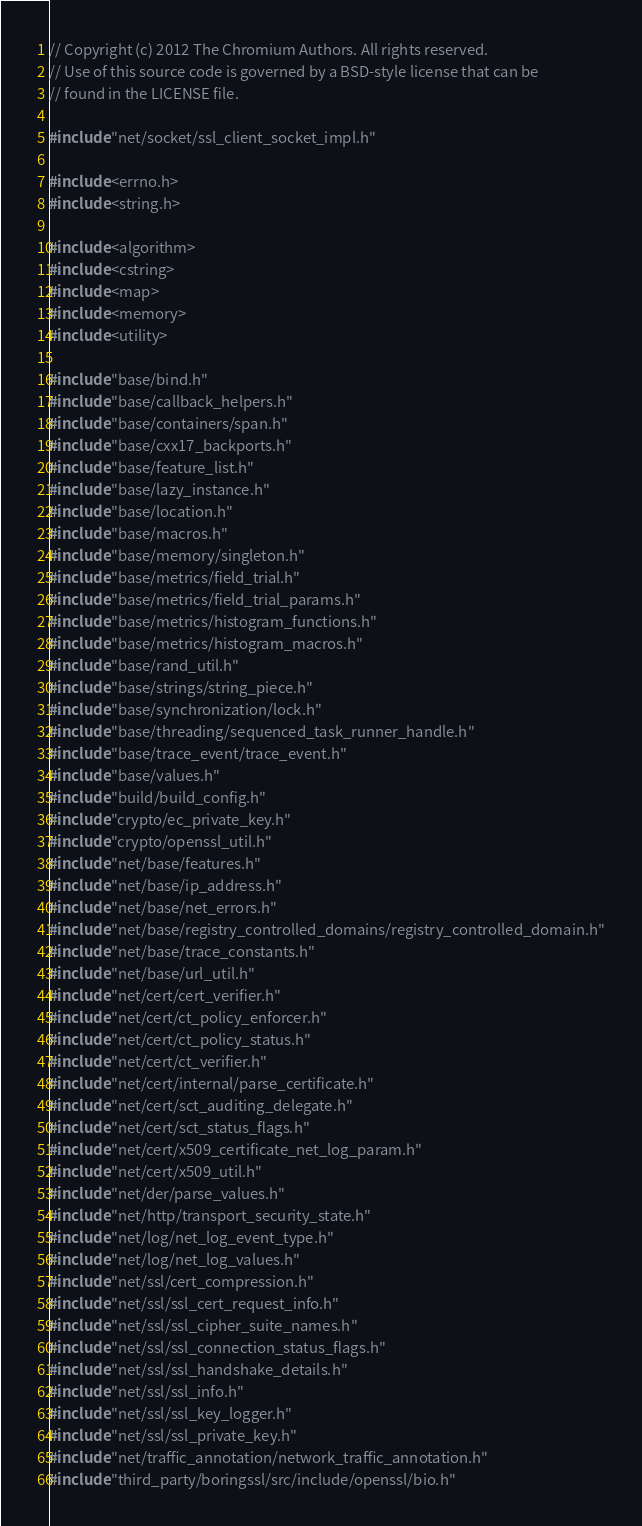Convert code to text. <code><loc_0><loc_0><loc_500><loc_500><_C++_>// Copyright (c) 2012 The Chromium Authors. All rights reserved.
// Use of this source code is governed by a BSD-style license that can be
// found in the LICENSE file.

#include "net/socket/ssl_client_socket_impl.h"

#include <errno.h>
#include <string.h>

#include <algorithm>
#include <cstring>
#include <map>
#include <memory>
#include <utility>

#include "base/bind.h"
#include "base/callback_helpers.h"
#include "base/containers/span.h"
#include "base/cxx17_backports.h"
#include "base/feature_list.h"
#include "base/lazy_instance.h"
#include "base/location.h"
#include "base/macros.h"
#include "base/memory/singleton.h"
#include "base/metrics/field_trial.h"
#include "base/metrics/field_trial_params.h"
#include "base/metrics/histogram_functions.h"
#include "base/metrics/histogram_macros.h"
#include "base/rand_util.h"
#include "base/strings/string_piece.h"
#include "base/synchronization/lock.h"
#include "base/threading/sequenced_task_runner_handle.h"
#include "base/trace_event/trace_event.h"
#include "base/values.h"
#include "build/build_config.h"
#include "crypto/ec_private_key.h"
#include "crypto/openssl_util.h"
#include "net/base/features.h"
#include "net/base/ip_address.h"
#include "net/base/net_errors.h"
#include "net/base/registry_controlled_domains/registry_controlled_domain.h"
#include "net/base/trace_constants.h"
#include "net/base/url_util.h"
#include "net/cert/cert_verifier.h"
#include "net/cert/ct_policy_enforcer.h"
#include "net/cert/ct_policy_status.h"
#include "net/cert/ct_verifier.h"
#include "net/cert/internal/parse_certificate.h"
#include "net/cert/sct_auditing_delegate.h"
#include "net/cert/sct_status_flags.h"
#include "net/cert/x509_certificate_net_log_param.h"
#include "net/cert/x509_util.h"
#include "net/der/parse_values.h"
#include "net/http/transport_security_state.h"
#include "net/log/net_log_event_type.h"
#include "net/log/net_log_values.h"
#include "net/ssl/cert_compression.h"
#include "net/ssl/ssl_cert_request_info.h"
#include "net/ssl/ssl_cipher_suite_names.h"
#include "net/ssl/ssl_connection_status_flags.h"
#include "net/ssl/ssl_handshake_details.h"
#include "net/ssl/ssl_info.h"
#include "net/ssl/ssl_key_logger.h"
#include "net/ssl/ssl_private_key.h"
#include "net/traffic_annotation/network_traffic_annotation.h"
#include "third_party/boringssl/src/include/openssl/bio.h"</code> 